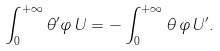<formula> <loc_0><loc_0><loc_500><loc_500>\int _ { 0 } ^ { + \infty } \theta ^ { \prime } \varphi \, U = - \int _ { 0 } ^ { + \infty } \theta \, \varphi \, U ^ { \prime } .</formula> 